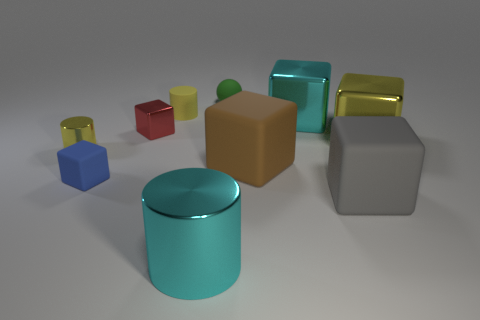How many big green metallic spheres are there?
Ensure brevity in your answer.  0. Is the number of brown matte things that are in front of the large brown matte cube less than the number of large cyan objects that are behind the large gray rubber object?
Your answer should be very brief. Yes. Are there fewer gray things on the left side of the blue rubber cube than gray matte objects?
Provide a succinct answer. Yes. What is the material of the tiny yellow object behind the yellow cylinder in front of the metal block that is right of the cyan block?
Provide a succinct answer. Rubber. How many things are rubber things that are on the left side of the large gray rubber block or things that are on the right side of the big gray rubber thing?
Offer a terse response. 5. What is the material of the blue thing that is the same shape as the gray thing?
Keep it short and to the point. Rubber. How many matte things are green cylinders or large cylinders?
Give a very brief answer. 0. What shape is the small red thing that is the same material as the yellow cube?
Keep it short and to the point. Cube. What number of large cyan objects have the same shape as the blue rubber object?
Your response must be concise. 1. There is a yellow object that is left of the red metal object; is it the same shape as the gray object to the right of the big cyan cylinder?
Your answer should be compact. No. 